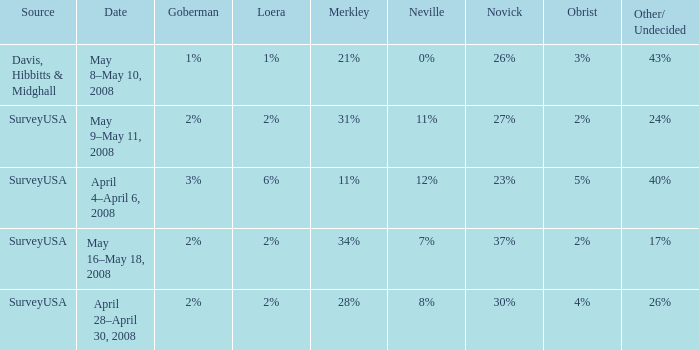Which Novick has a Source of surveyusa, and a Neville of 8%? 30%. 